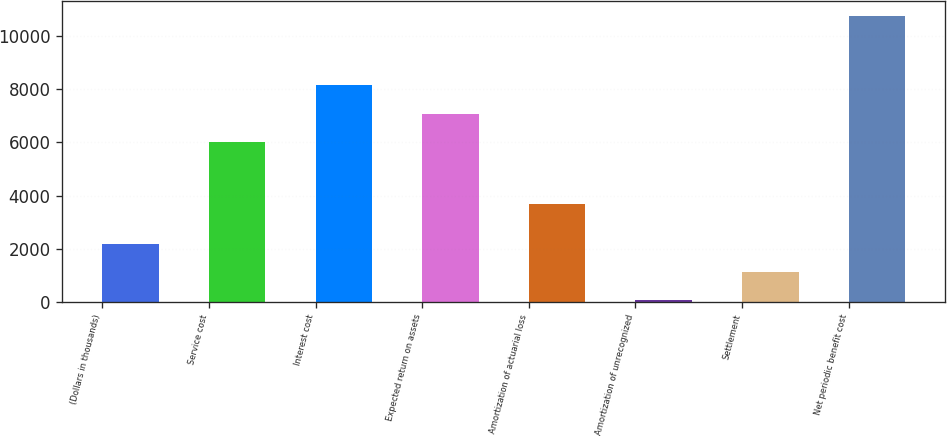<chart> <loc_0><loc_0><loc_500><loc_500><bar_chart><fcel>(Dollars in thousands)<fcel>Service cost<fcel>Interest cost<fcel>Expected return on assets<fcel>Amortization of actuarial loss<fcel>Amortization of unrecognized<fcel>Settlement<fcel>Net periodic benefit cost<nl><fcel>2193.6<fcel>6015<fcel>8159.6<fcel>7087.3<fcel>3663<fcel>49<fcel>1121.3<fcel>10772<nl></chart> 